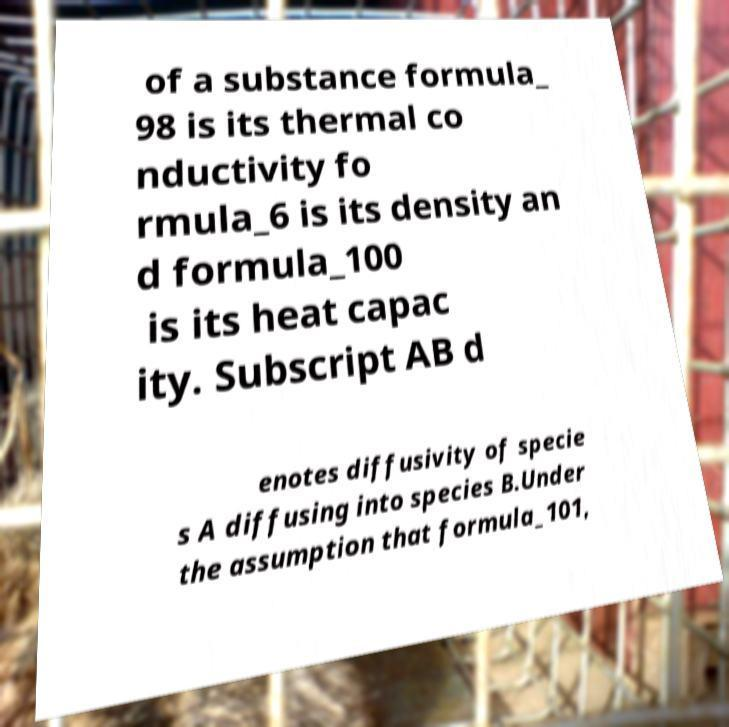Please read and relay the text visible in this image. What does it say? of a substance formula_ 98 is its thermal co nductivity fo rmula_6 is its density an d formula_100 is its heat capac ity. Subscript AB d enotes diffusivity of specie s A diffusing into species B.Under the assumption that formula_101, 